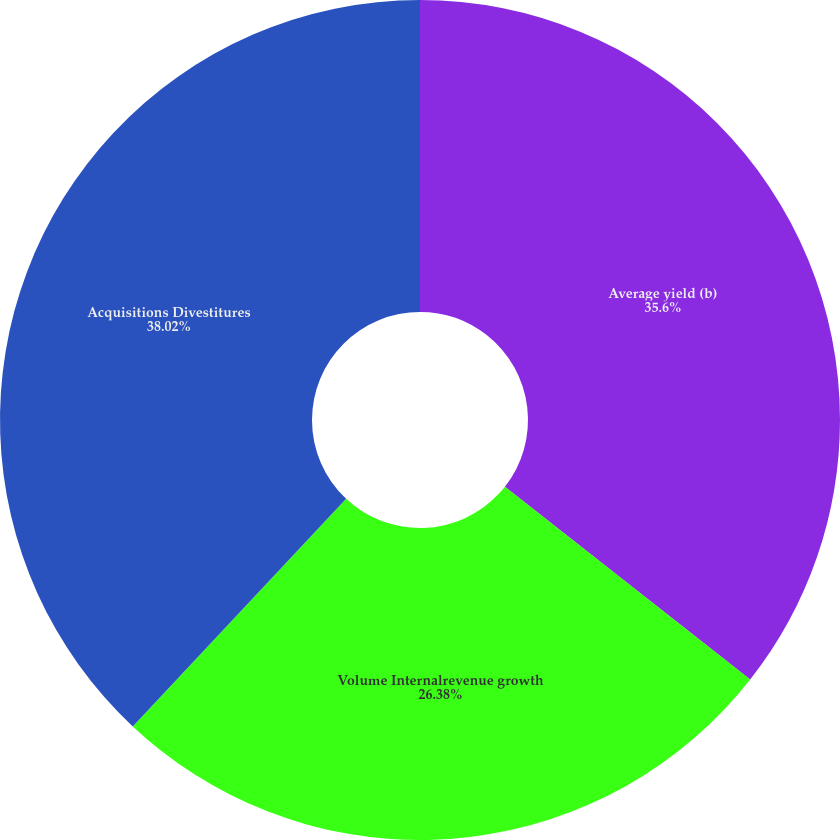Convert chart to OTSL. <chart><loc_0><loc_0><loc_500><loc_500><pie_chart><fcel>Average yield (b)<fcel>Volume Internalrevenue growth<fcel>Acquisitions Divestitures<nl><fcel>35.6%<fcel>26.38%<fcel>38.01%<nl></chart> 